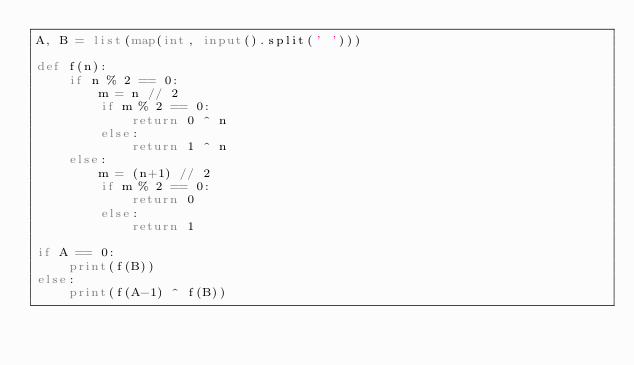Convert code to text. <code><loc_0><loc_0><loc_500><loc_500><_Python_>A, B = list(map(int, input().split(' ')))

def f(n):
    if n % 2 == 0:
        m = n // 2
        if m % 2 == 0:
            return 0 ^ n
        else:
            return 1 ^ n
    else:
        m = (n+1) // 2
        if m % 2 == 0:
            return 0
        else:
            return 1

if A == 0:
    print(f(B))
else:
    print(f(A-1) ^ f(B))</code> 